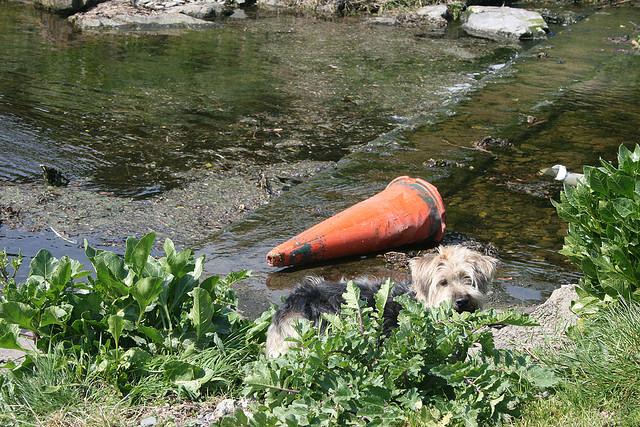What shape does the orange item have?
Short answer required. Cone. What color is the cone?
Give a very brief answer. Orange. What color is the water?
Write a very short answer. Green. 